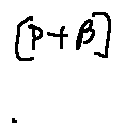<formula> <loc_0><loc_0><loc_500><loc_500>[ P + \beta ]</formula> 